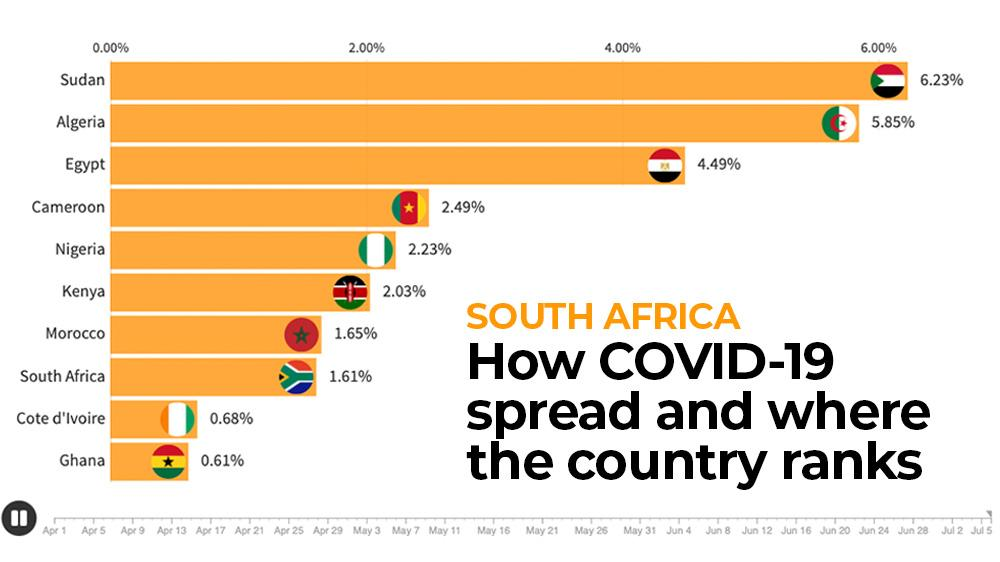Outline some significant characteristics in this image. The spread of disease in South Africa is less than in Morocco, with a ratio of 0.04. According to recent data, Egypt, a country in South Africa, ranks third in terms of the spread of Covid-19. There are three countries in South Africa where the number of Covid cases is greater than 4%. Morocco has the seventh highest number of COVID-19 cases among countries. Cote d'Ivoire has the second lowest number of COVID-19 cases. 